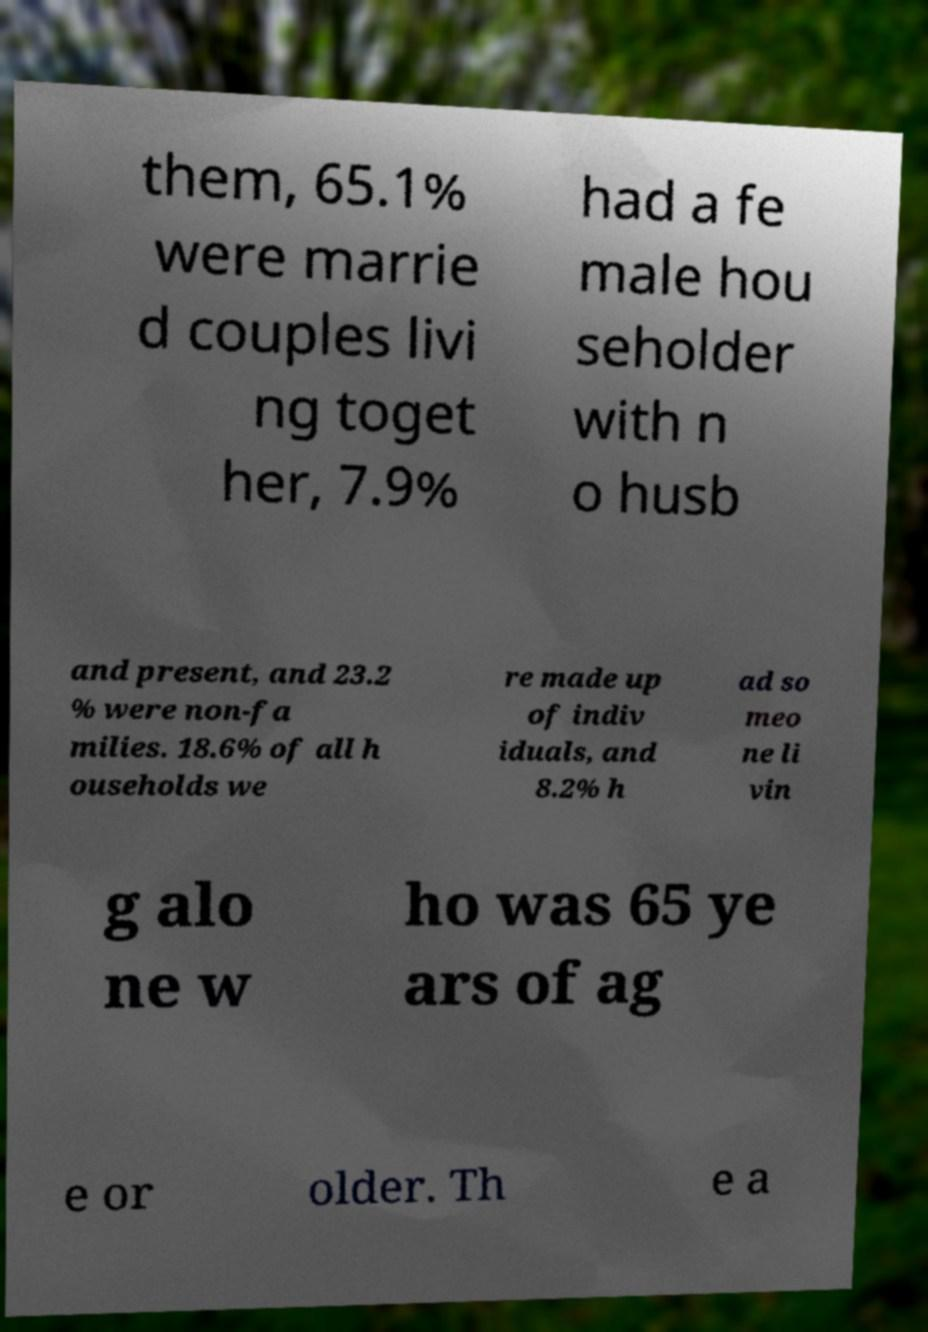For documentation purposes, I need the text within this image transcribed. Could you provide that? them, 65.1% were marrie d couples livi ng toget her, 7.9% had a fe male hou seholder with n o husb and present, and 23.2 % were non-fa milies. 18.6% of all h ouseholds we re made up of indiv iduals, and 8.2% h ad so meo ne li vin g alo ne w ho was 65 ye ars of ag e or older. Th e a 